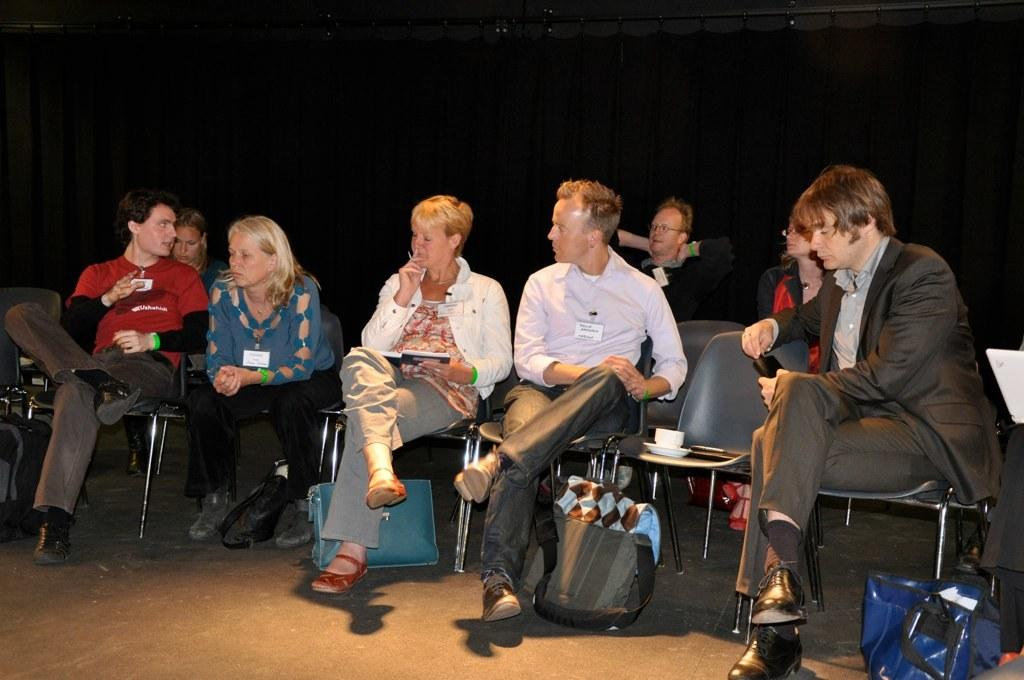What are the people in the image doing? There are many persons sitting on chairs in the image. Can you describe the lady holding a book? The lady is holding a book and wearing a white shirt. What can be seen on the floor in the image? There are bags on the floor. What is the color of the background in the image? The background is black. What type of bird is flying across the room in the image? There is no bird visible in the image; the background is black, and the focus is on the people sitting on chairs and the lady holding a book. 